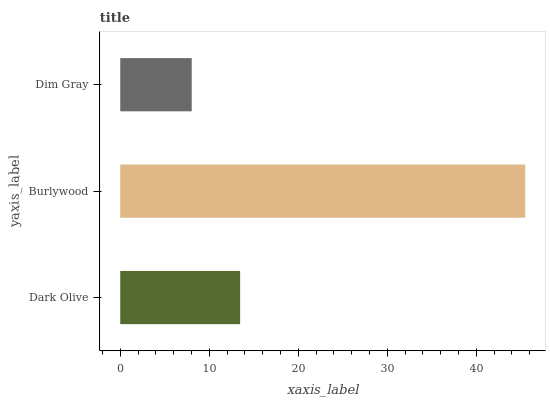Is Dim Gray the minimum?
Answer yes or no. Yes. Is Burlywood the maximum?
Answer yes or no. Yes. Is Burlywood the minimum?
Answer yes or no. No. Is Dim Gray the maximum?
Answer yes or no. No. Is Burlywood greater than Dim Gray?
Answer yes or no. Yes. Is Dim Gray less than Burlywood?
Answer yes or no. Yes. Is Dim Gray greater than Burlywood?
Answer yes or no. No. Is Burlywood less than Dim Gray?
Answer yes or no. No. Is Dark Olive the high median?
Answer yes or no. Yes. Is Dark Olive the low median?
Answer yes or no. Yes. Is Dim Gray the high median?
Answer yes or no. No. Is Dim Gray the low median?
Answer yes or no. No. 